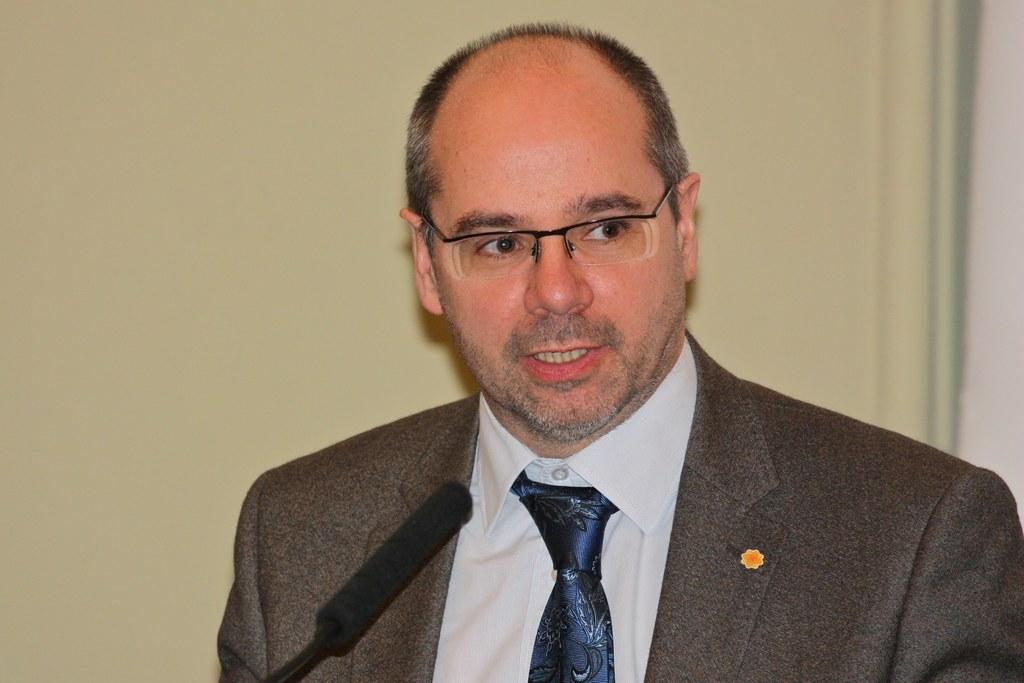Who is the main subject in the image? There is a man in the image. What is the man wearing? The man is wearing a suit. What is the man doing in the image? The man is speaking on a microphone. In which direction is the man looking? The man is looking to the right. What can be seen in the background of the image? There is a wall in the background of the image. What hobbies does the man have outside of his speaking engagements? The image does not provide information about the man's hobbies outside of his speaking engagements. 